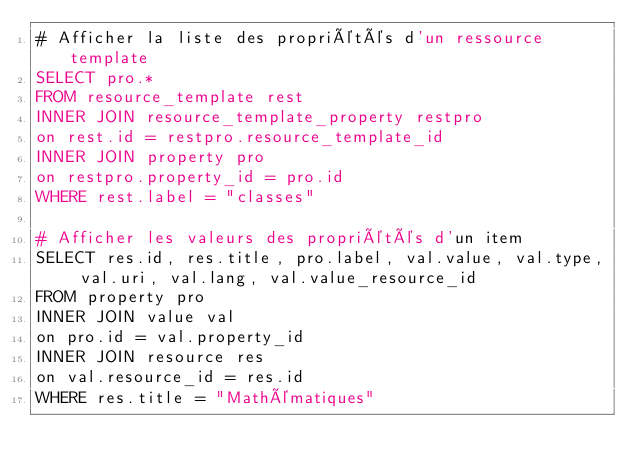Convert code to text. <code><loc_0><loc_0><loc_500><loc_500><_SQL_># Afficher la liste des propriétés d'un ressource template
SELECT pro.*
FROM resource_template rest
INNER JOIN resource_template_property restpro
on rest.id = restpro.resource_template_id
INNER JOIN property pro
on restpro.property_id = pro.id
WHERE rest.label = "classes"

# Afficher les valeurs des propriétés d'un item
SELECT res.id, res.title, pro.label, val.value, val.type, val.uri, val.lang, val.value_resource_id
FROM property pro
INNER JOIN value val
on pro.id = val.property_id
INNER JOIN resource res
on val.resource_id = res.id
WHERE res.title = "Mathématiques"</code> 